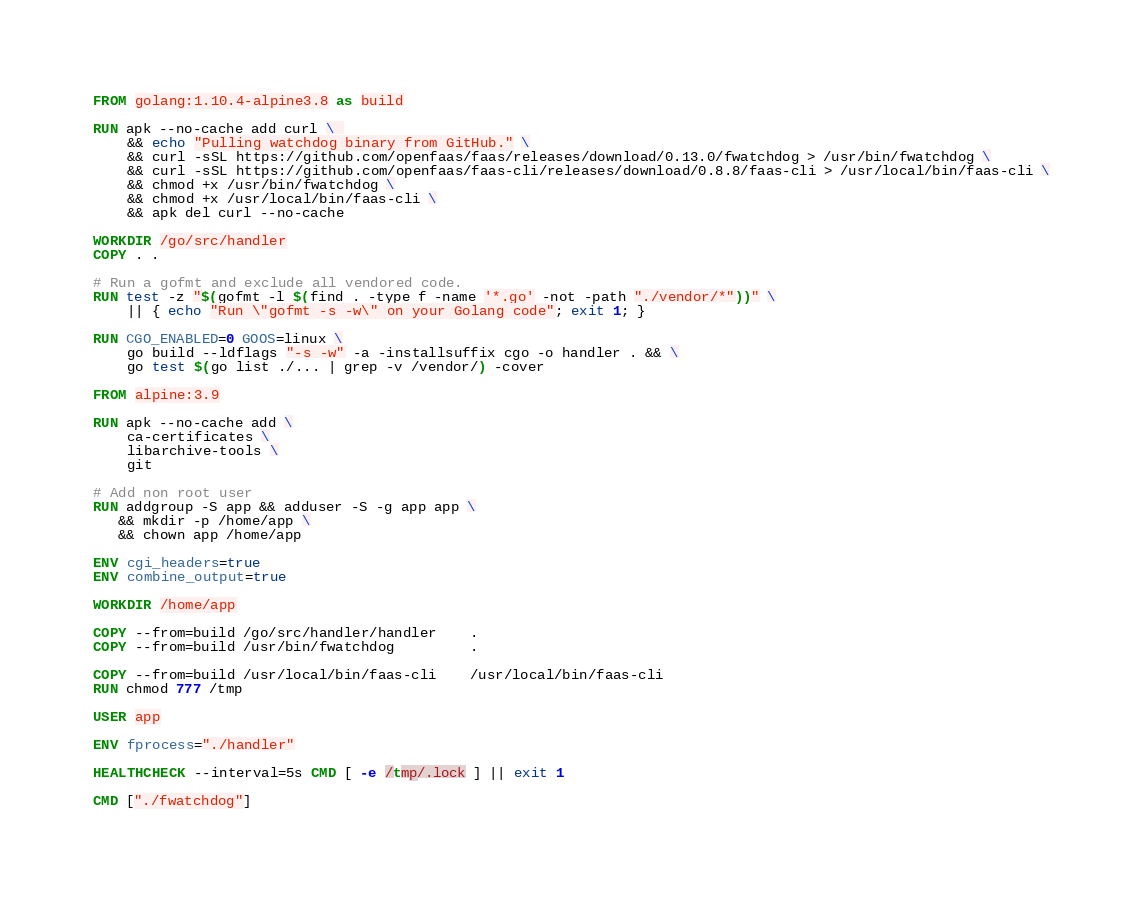Convert code to text. <code><loc_0><loc_0><loc_500><loc_500><_Dockerfile_>FROM golang:1.10.4-alpine3.8 as build

RUN apk --no-cache add curl \ 
    && echo "Pulling watchdog binary from GitHub." \
    && curl -sSL https://github.com/openfaas/faas/releases/download/0.13.0/fwatchdog > /usr/bin/fwatchdog \
    && curl -sSL https://github.com/openfaas/faas-cli/releases/download/0.8.8/faas-cli > /usr/local/bin/faas-cli \
    && chmod +x /usr/bin/fwatchdog \
    && chmod +x /usr/local/bin/faas-cli \
    && apk del curl --no-cache

WORKDIR /go/src/handler
COPY . .

# Run a gofmt and exclude all vendored code.
RUN test -z "$(gofmt -l $(find . -type f -name '*.go' -not -path "./vendor/*"))" \
    || { echo "Run \"gofmt -s -w\" on your Golang code"; exit 1; }

RUN CGO_ENABLED=0 GOOS=linux \
    go build --ldflags "-s -w" -a -installsuffix cgo -o handler . && \
    go test $(go list ./... | grep -v /vendor/) -cover

FROM alpine:3.9

RUN apk --no-cache add \
    ca-certificates \
    libarchive-tools \
    git

# Add non root user
RUN addgroup -S app && adduser -S -g app app \
   && mkdir -p /home/app \
   && chown app /home/app

ENV cgi_headers=true
ENV combine_output=true

WORKDIR /home/app

COPY --from=build /go/src/handler/handler    .
COPY --from=build /usr/bin/fwatchdog         .

COPY --from=build /usr/local/bin/faas-cli    /usr/local/bin/faas-cli
RUN chmod 777 /tmp

USER app

ENV fprocess="./handler"

HEALTHCHECK --interval=5s CMD [ -e /tmp/.lock ] || exit 1

CMD ["./fwatchdog"]
</code> 